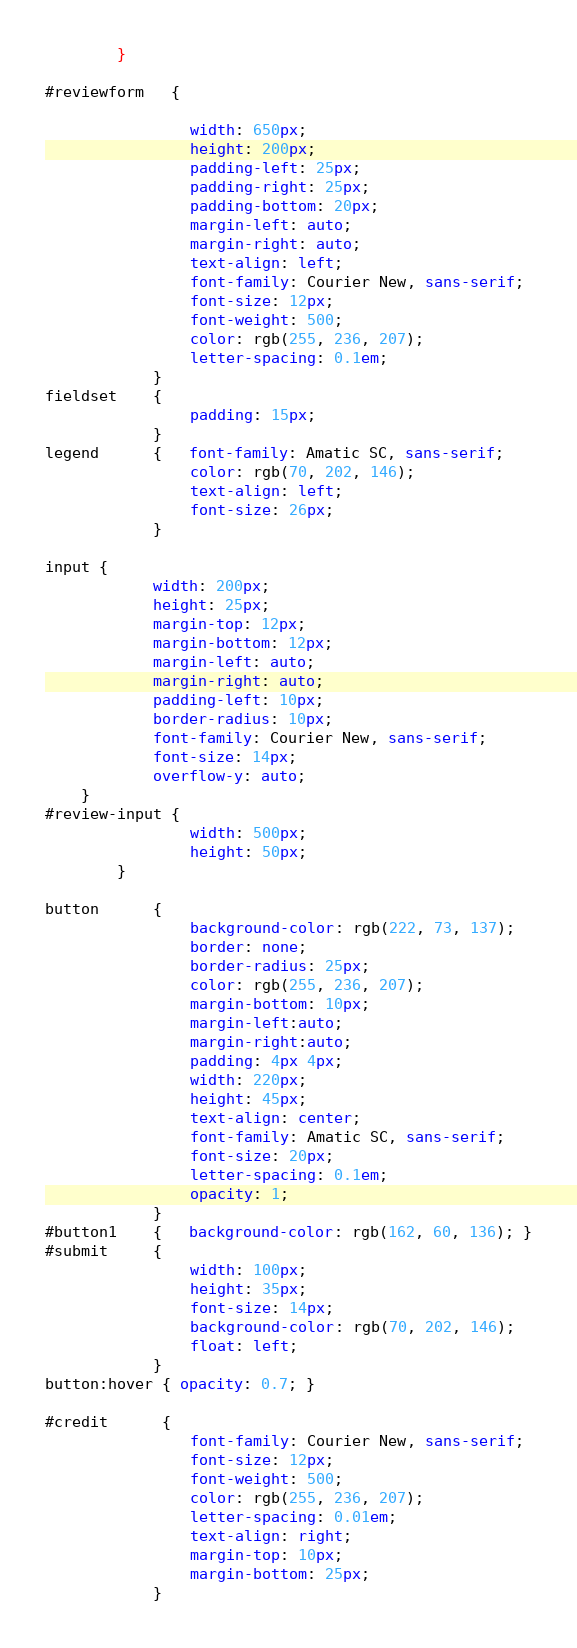<code> <loc_0><loc_0><loc_500><loc_500><_CSS_>        }

#reviewform   {
    
                width: 650px;
                height: 200px;
                padding-left: 25px;
                padding-right: 25px;
                padding-bottom: 20px;
                margin-left: auto;
                margin-right: auto;
                text-align: left;
                font-family: Courier New, sans-serif;
                font-size: 12px;
                font-weight: 500;
                color: rgb(255, 236, 207);
                letter-spacing: 0.1em;
            }
fieldset    {
                padding: 15px;
            }
legend      {   font-family: Amatic SC, sans-serif;
                color: rgb(70, 202, 146);
                text-align: left;
                font-size: 26px; 
            }

input {
            width: 200px;
            height: 25px;
            margin-top: 12px;
            margin-bottom: 12px;
            margin-left: auto;
            margin-right: auto;
            padding-left: 10px;
            border-radius: 10px;
            font-family: Courier New, sans-serif;
            font-size: 14px;
            overflow-y: auto;
    }
#review-input {
                width: 500px;
                height: 50px;
        }

button      {
                background-color: rgb(222, 73, 137);
                border: none;
                border-radius: 25px;
                color: rgb(255, 236, 207);
                margin-bottom: 10px;
                margin-left:auto;
                margin-right:auto;
                padding: 4px 4px;
                width: 220px;
                height: 45px;
                text-align: center;
                font-family: Amatic SC, sans-serif;
                font-size: 20px;
                letter-spacing: 0.1em;
                opacity: 1;
            }
#button1    {   background-color: rgb(162, 60, 136); }
#submit     {
                width: 100px;
                height: 35px;
                font-size: 14px;
                background-color: rgb(70, 202, 146);
                float: left;
            }
button:hover { opacity: 0.7; }

#credit      {
                font-family: Courier New, sans-serif;
                font-size: 12px;
                font-weight: 500;
                color: rgb(255, 236, 207);
                letter-spacing: 0.01em;
                text-align: right;
                margin-top: 10px;
                margin-bottom: 25px;
            }
</code> 